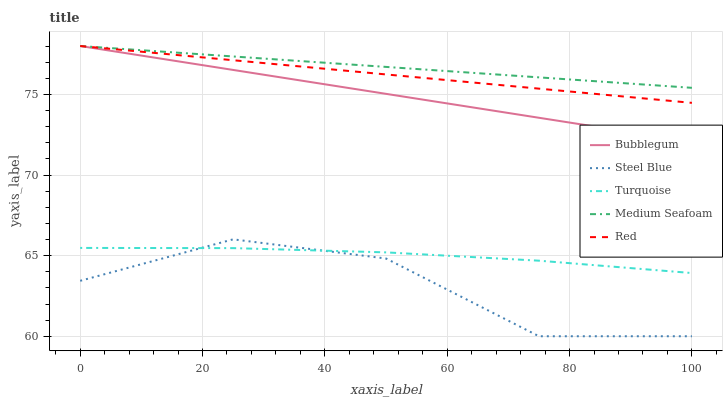Does Steel Blue have the minimum area under the curve?
Answer yes or no. Yes. Does Medium Seafoam have the maximum area under the curve?
Answer yes or no. Yes. Does Turquoise have the minimum area under the curve?
Answer yes or no. No. Does Turquoise have the maximum area under the curve?
Answer yes or no. No. Is Bubblegum the smoothest?
Answer yes or no. Yes. Is Steel Blue the roughest?
Answer yes or no. Yes. Is Turquoise the smoothest?
Answer yes or no. No. Is Turquoise the roughest?
Answer yes or no. No. Does Steel Blue have the lowest value?
Answer yes or no. Yes. Does Turquoise have the lowest value?
Answer yes or no. No. Does Medium Seafoam have the highest value?
Answer yes or no. Yes. Does Steel Blue have the highest value?
Answer yes or no. No. Is Steel Blue less than Medium Seafoam?
Answer yes or no. Yes. Is Red greater than Turquoise?
Answer yes or no. Yes. Does Turquoise intersect Steel Blue?
Answer yes or no. Yes. Is Turquoise less than Steel Blue?
Answer yes or no. No. Is Turquoise greater than Steel Blue?
Answer yes or no. No. Does Steel Blue intersect Medium Seafoam?
Answer yes or no. No. 